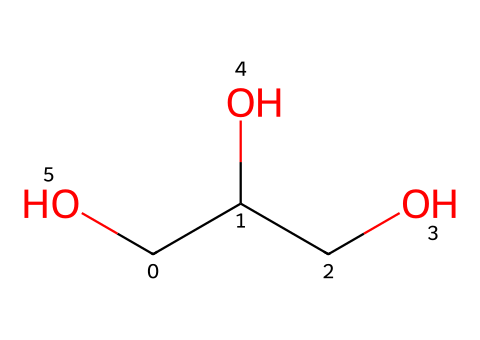What is the name of the chemical represented by this SMILES? The SMILES notation presents a linear and branched structure that can be traced to yield the name 'glycerin' or 'glycerol.' Hence, based on the arrangement of carbon and hydroxyl groups, we can determine its common name.
Answer: glycerin How many carbon atoms are in glycerin? Analyzing the SMILES, there are three carbon atoms (C) present in the structure. This can be counted directly from the notation, where each 'C' stands for a carbon atom, giving us three in total.
Answer: 3 What is the functional group present in glycerin? The presence of -OH groups in the structure indicates that glycerin contains hydroxyl functional groups which are representative of alcohols. Therefore, examining the structure shows these functional groups clearly.
Answer: hydroxyl What is the total number of oxygen atoms in glycerin? By reviewing the SMILES representation, we find there are three instances of oxygen (O) present in the structure, indicated clearly in the notation. Each 'O' corresponds to one oxygen atom, totaling to three.
Answer: 3 How many hydrogen atoms are in glycerin? Each carbon in the structure typically bonds with hydrogen. Glycerin has a total of 8 hydrogen atoms when taking into account the hydrogen atoms attached to each carbon along with the ones introduced by alcohol groups. Thus, summing these gives a total of 8.
Answer: 8 What type of chemical is glycerin considered in cosmetics? Glycerin is primarily recognized as a humectant in cosmetic applications because it effectively draws moisture into the skin, making it beneficial for hydration. Its structural attributes facilitate this function, being an effective moisturizing agent.
Answer: humectant Is glycerin polar or nonpolar? The presence of multiple hydroxyl groups in glycerin results in a polar molecule. This is derived from the electronegative oxygen atoms that create polar bonds with hydrogen and carbon. Thus, the overall molecular composition indicates a polarity.
Answer: polar 